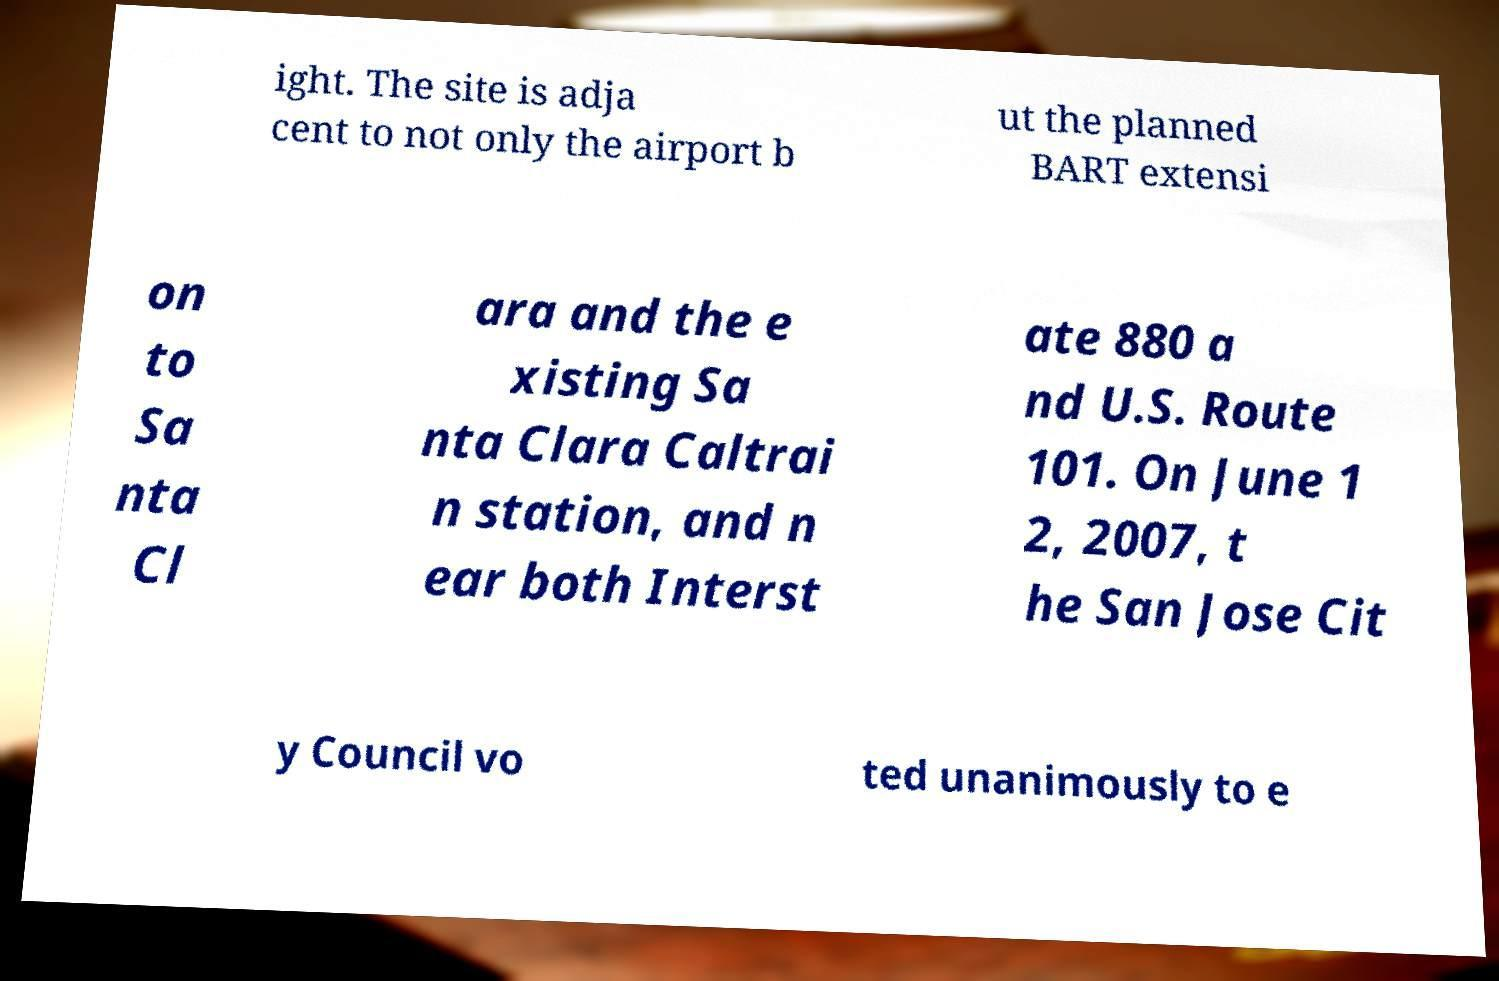Could you assist in decoding the text presented in this image and type it out clearly? ight. The site is adja cent to not only the airport b ut the planned BART extensi on to Sa nta Cl ara and the e xisting Sa nta Clara Caltrai n station, and n ear both Interst ate 880 a nd U.S. Route 101. On June 1 2, 2007, t he San Jose Cit y Council vo ted unanimously to e 